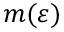Convert formula to latex. <formula><loc_0><loc_0><loc_500><loc_500>m ( \varepsilon )</formula> 